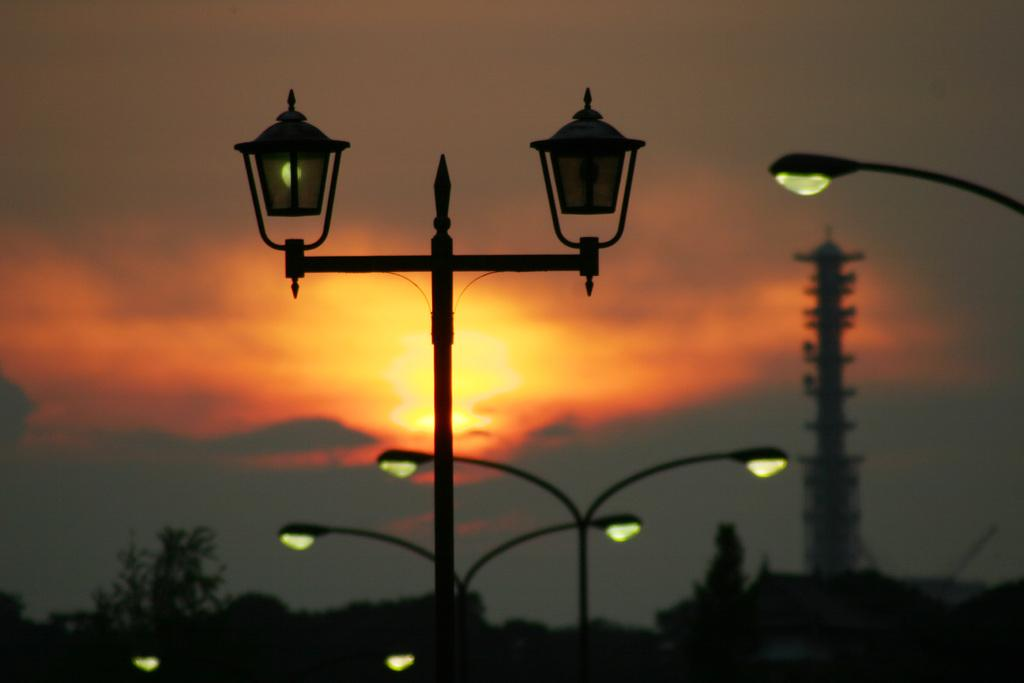What type of structures can be seen in the image? There are street lights, poles, and a tower in the image. What type of vegetation is present in the image? There are trees in the image. What other objects can be seen in the image besides the structures and vegetation? There are other objects in the image. What is visible in the background of the image? The sky is visible in the background of the image. How many children are playing on the shelf in the image? There are no children or shelves present in the image. What is the value of the tower in the image? The value of the tower cannot be determined from the image, as it is not a real-world object with a monetary value. 